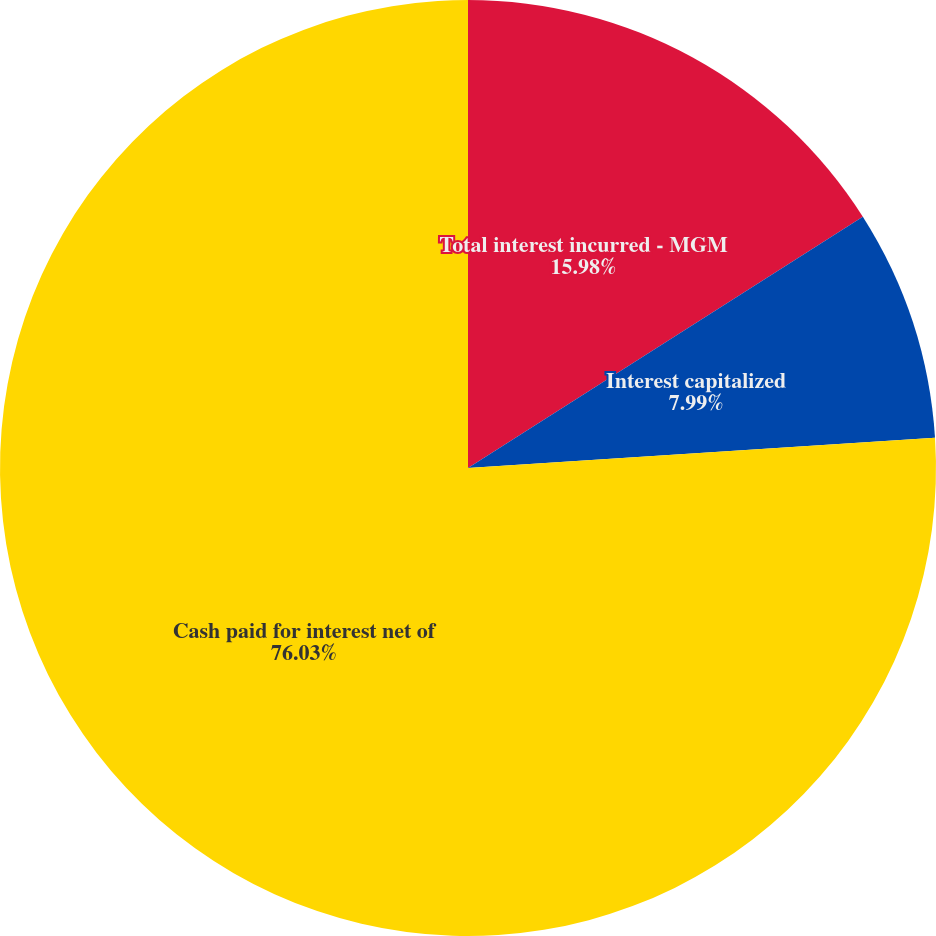Convert chart to OTSL. <chart><loc_0><loc_0><loc_500><loc_500><pie_chart><fcel>Total interest incurred - MGM<fcel>Interest capitalized<fcel>Cash paid for interest net of<fcel>End-of-year weighted average<nl><fcel>15.98%<fcel>7.99%<fcel>76.03%<fcel>0.0%<nl></chart> 